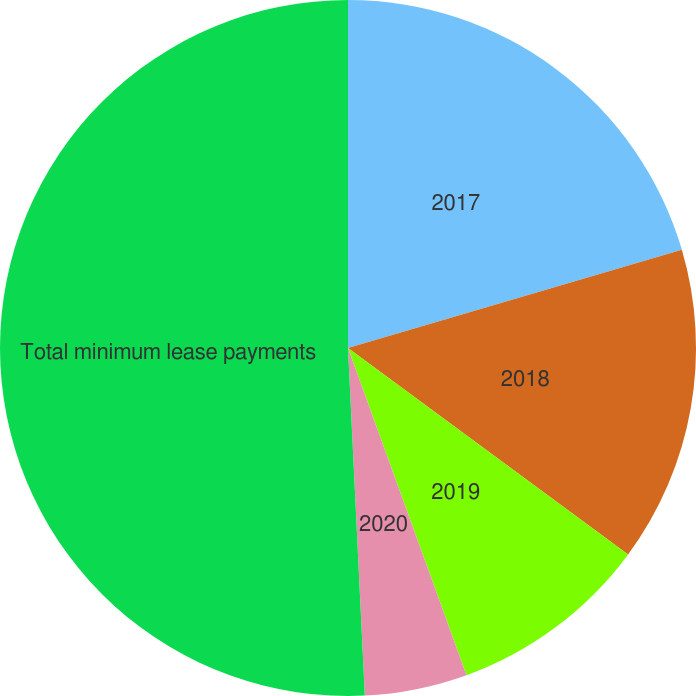Convert chart to OTSL. <chart><loc_0><loc_0><loc_500><loc_500><pie_chart><fcel>2017<fcel>2018<fcel>2019<fcel>2020<fcel>Total minimum lease payments<nl><fcel>20.45%<fcel>14.66%<fcel>9.36%<fcel>4.76%<fcel>50.77%<nl></chart> 